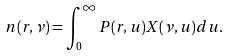Convert formula to latex. <formula><loc_0><loc_0><loc_500><loc_500>n ( r , \nu ) = \int _ { 0 } ^ { \infty } P ( r , u ) X ( \nu , u ) d u .</formula> 